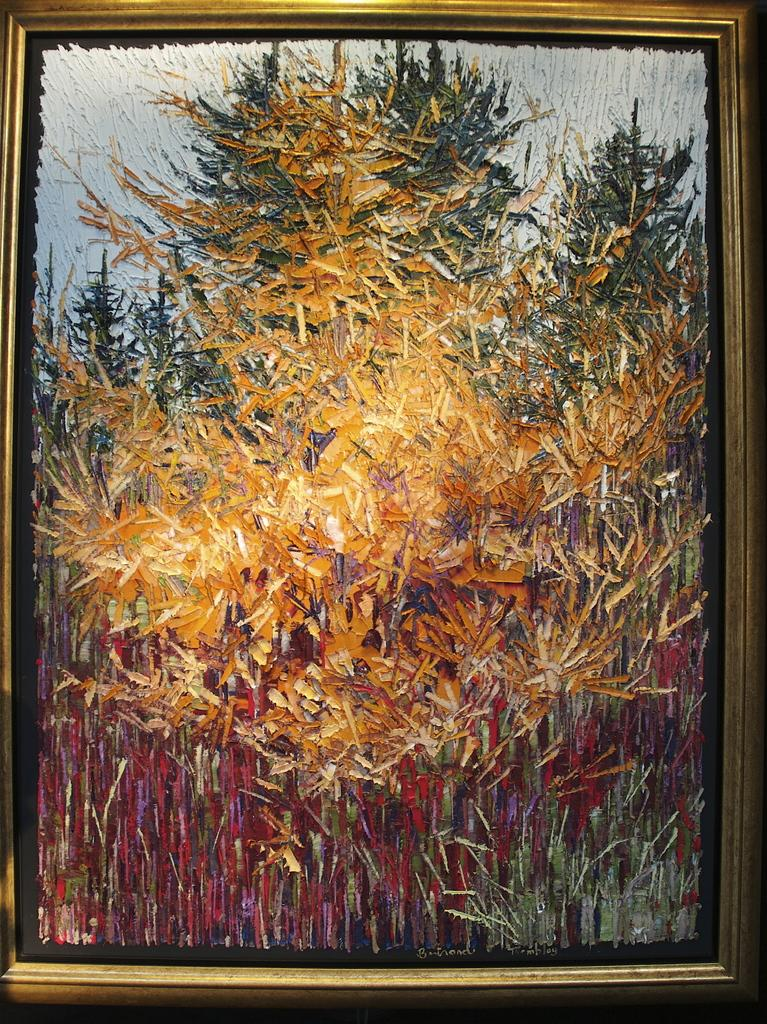What object in the image contains a visual representation? There is a photo frame in the image that contains an abstract painting. Can you describe the artwork on the photo frame? The artwork on the photo frame is an abstract painting. What type of ice does the painting depict in the image? The painting on the photo frame does not depict ice; it is an abstract painting. 